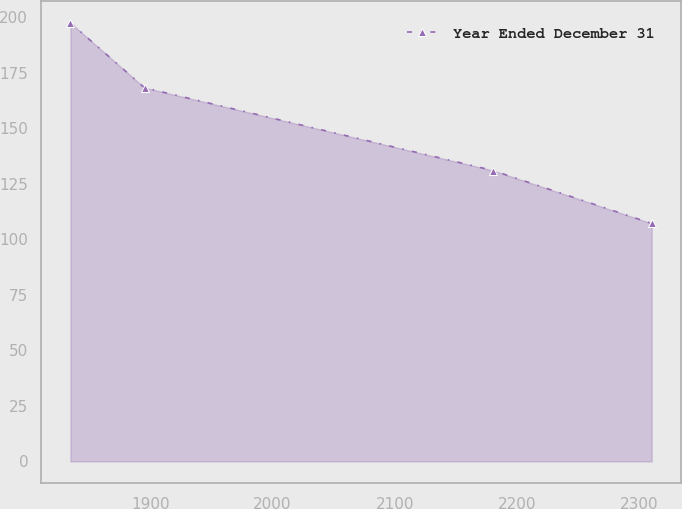<chart> <loc_0><loc_0><loc_500><loc_500><line_chart><ecel><fcel>Year Ended December 31<nl><fcel>1834.74<fcel>197.57<nl><fcel>1895.3<fcel>168.35<nl><fcel>2180.24<fcel>131.06<nl><fcel>2309.89<fcel>107.2<nl></chart> 